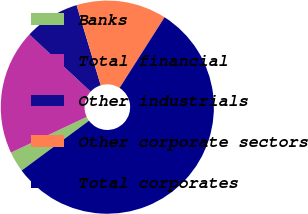Convert chart to OTSL. <chart><loc_0><loc_0><loc_500><loc_500><pie_chart><fcel>Banks<fcel>Total financial<fcel>Other industrials<fcel>Other corporate sectors<fcel>Total corporates<nl><fcel>3.13%<fcel>18.95%<fcel>8.4%<fcel>13.68%<fcel>55.84%<nl></chart> 